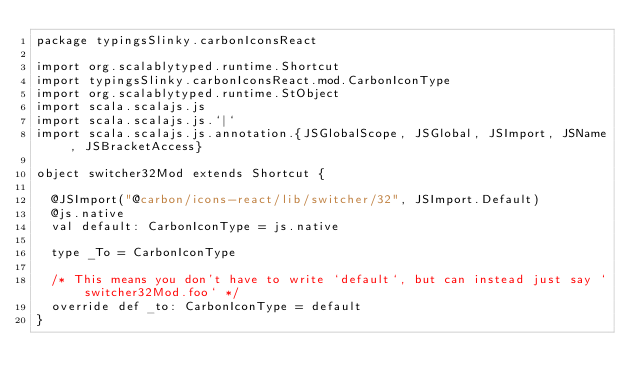<code> <loc_0><loc_0><loc_500><loc_500><_Scala_>package typingsSlinky.carbonIconsReact

import org.scalablytyped.runtime.Shortcut
import typingsSlinky.carbonIconsReact.mod.CarbonIconType
import org.scalablytyped.runtime.StObject
import scala.scalajs.js
import scala.scalajs.js.`|`
import scala.scalajs.js.annotation.{JSGlobalScope, JSGlobal, JSImport, JSName, JSBracketAccess}

object switcher32Mod extends Shortcut {
  
  @JSImport("@carbon/icons-react/lib/switcher/32", JSImport.Default)
  @js.native
  val default: CarbonIconType = js.native
  
  type _To = CarbonIconType
  
  /* This means you don't have to write `default`, but can instead just say `switcher32Mod.foo` */
  override def _to: CarbonIconType = default
}
</code> 